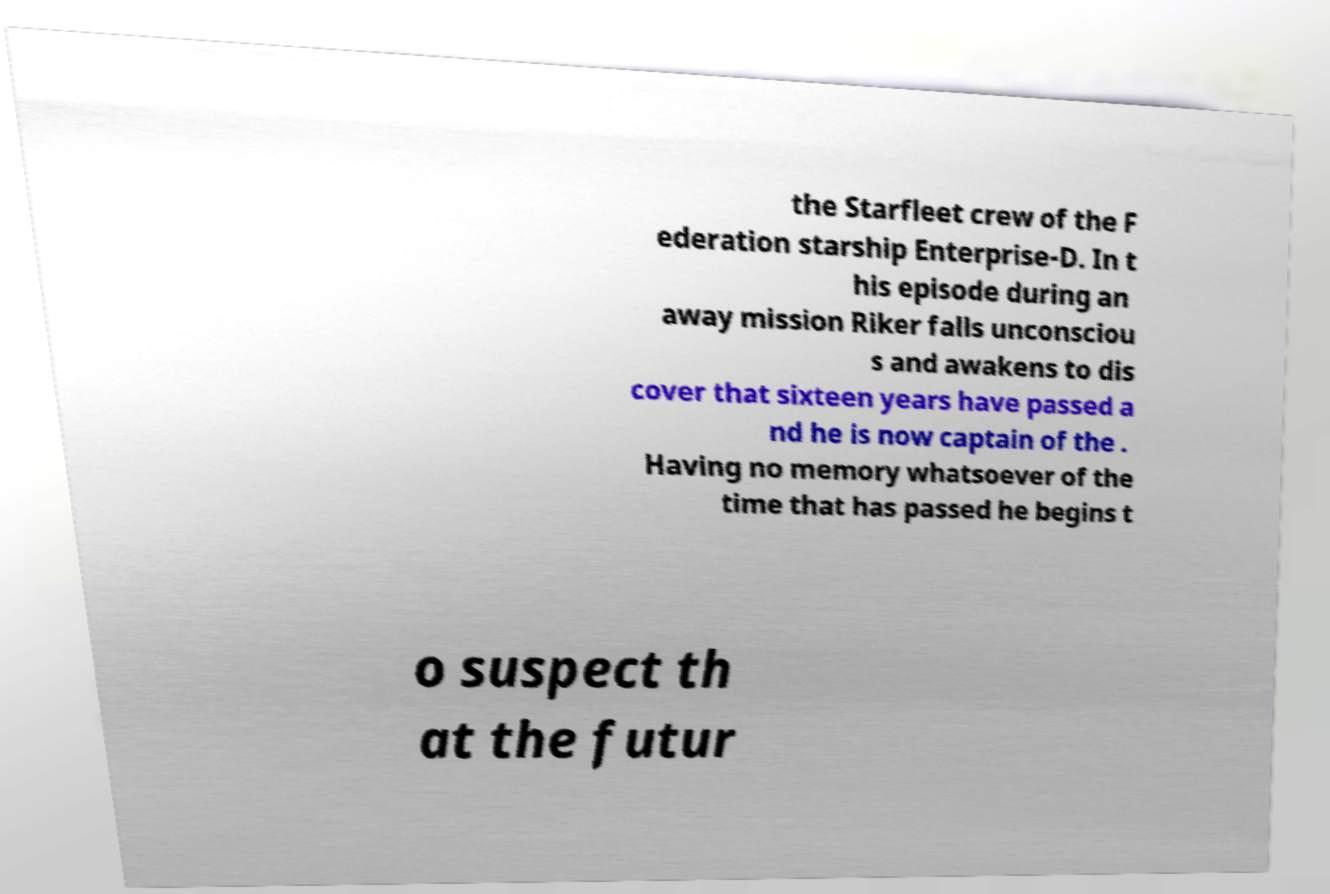Can you read and provide the text displayed in the image?This photo seems to have some interesting text. Can you extract and type it out for me? the Starfleet crew of the F ederation starship Enterprise-D. In t his episode during an away mission Riker falls unconsciou s and awakens to dis cover that sixteen years have passed a nd he is now captain of the . Having no memory whatsoever of the time that has passed he begins t o suspect th at the futur 